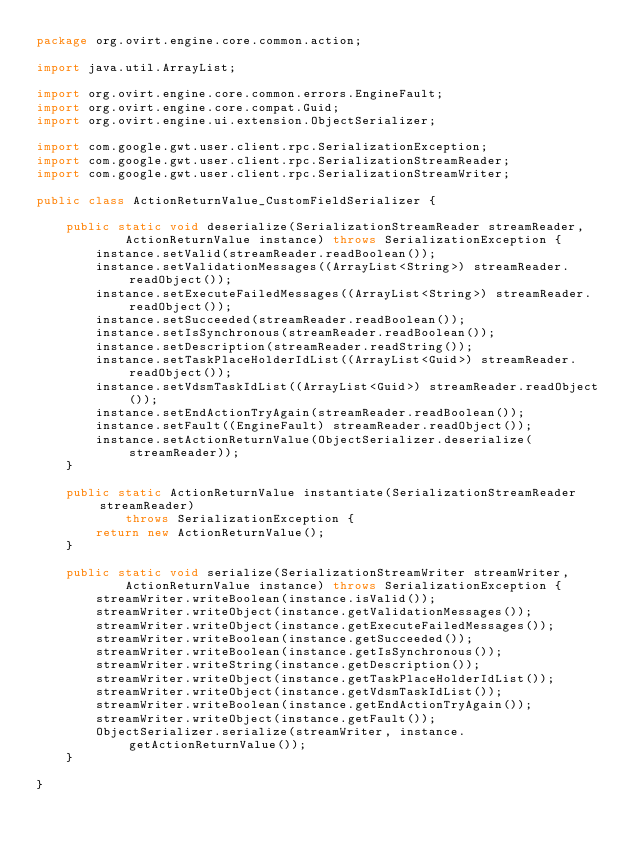<code> <loc_0><loc_0><loc_500><loc_500><_Java_>package org.ovirt.engine.core.common.action;

import java.util.ArrayList;

import org.ovirt.engine.core.common.errors.EngineFault;
import org.ovirt.engine.core.compat.Guid;
import org.ovirt.engine.ui.extension.ObjectSerializer;

import com.google.gwt.user.client.rpc.SerializationException;
import com.google.gwt.user.client.rpc.SerializationStreamReader;
import com.google.gwt.user.client.rpc.SerializationStreamWriter;

public class ActionReturnValue_CustomFieldSerializer {

    public static void deserialize(SerializationStreamReader streamReader,
            ActionReturnValue instance) throws SerializationException {
        instance.setValid(streamReader.readBoolean());
        instance.setValidationMessages((ArrayList<String>) streamReader.readObject());
        instance.setExecuteFailedMessages((ArrayList<String>) streamReader.readObject());
        instance.setSucceeded(streamReader.readBoolean());
        instance.setIsSynchronous(streamReader.readBoolean());
        instance.setDescription(streamReader.readString());
        instance.setTaskPlaceHolderIdList((ArrayList<Guid>) streamReader.readObject());
        instance.setVdsmTaskIdList((ArrayList<Guid>) streamReader.readObject());
        instance.setEndActionTryAgain(streamReader.readBoolean());
        instance.setFault((EngineFault) streamReader.readObject());
        instance.setActionReturnValue(ObjectSerializer.deserialize(streamReader));
    }

    public static ActionReturnValue instantiate(SerializationStreamReader streamReader)
            throws SerializationException {
        return new ActionReturnValue();
    }

    public static void serialize(SerializationStreamWriter streamWriter,
            ActionReturnValue instance) throws SerializationException {
        streamWriter.writeBoolean(instance.isValid());
        streamWriter.writeObject(instance.getValidationMessages());
        streamWriter.writeObject(instance.getExecuteFailedMessages());
        streamWriter.writeBoolean(instance.getSucceeded());
        streamWriter.writeBoolean(instance.getIsSynchronous());
        streamWriter.writeString(instance.getDescription());
        streamWriter.writeObject(instance.getTaskPlaceHolderIdList());
        streamWriter.writeObject(instance.getVdsmTaskIdList());
        streamWriter.writeBoolean(instance.getEndActionTryAgain());
        streamWriter.writeObject(instance.getFault());
        ObjectSerializer.serialize(streamWriter, instance.getActionReturnValue());
    }

}
</code> 